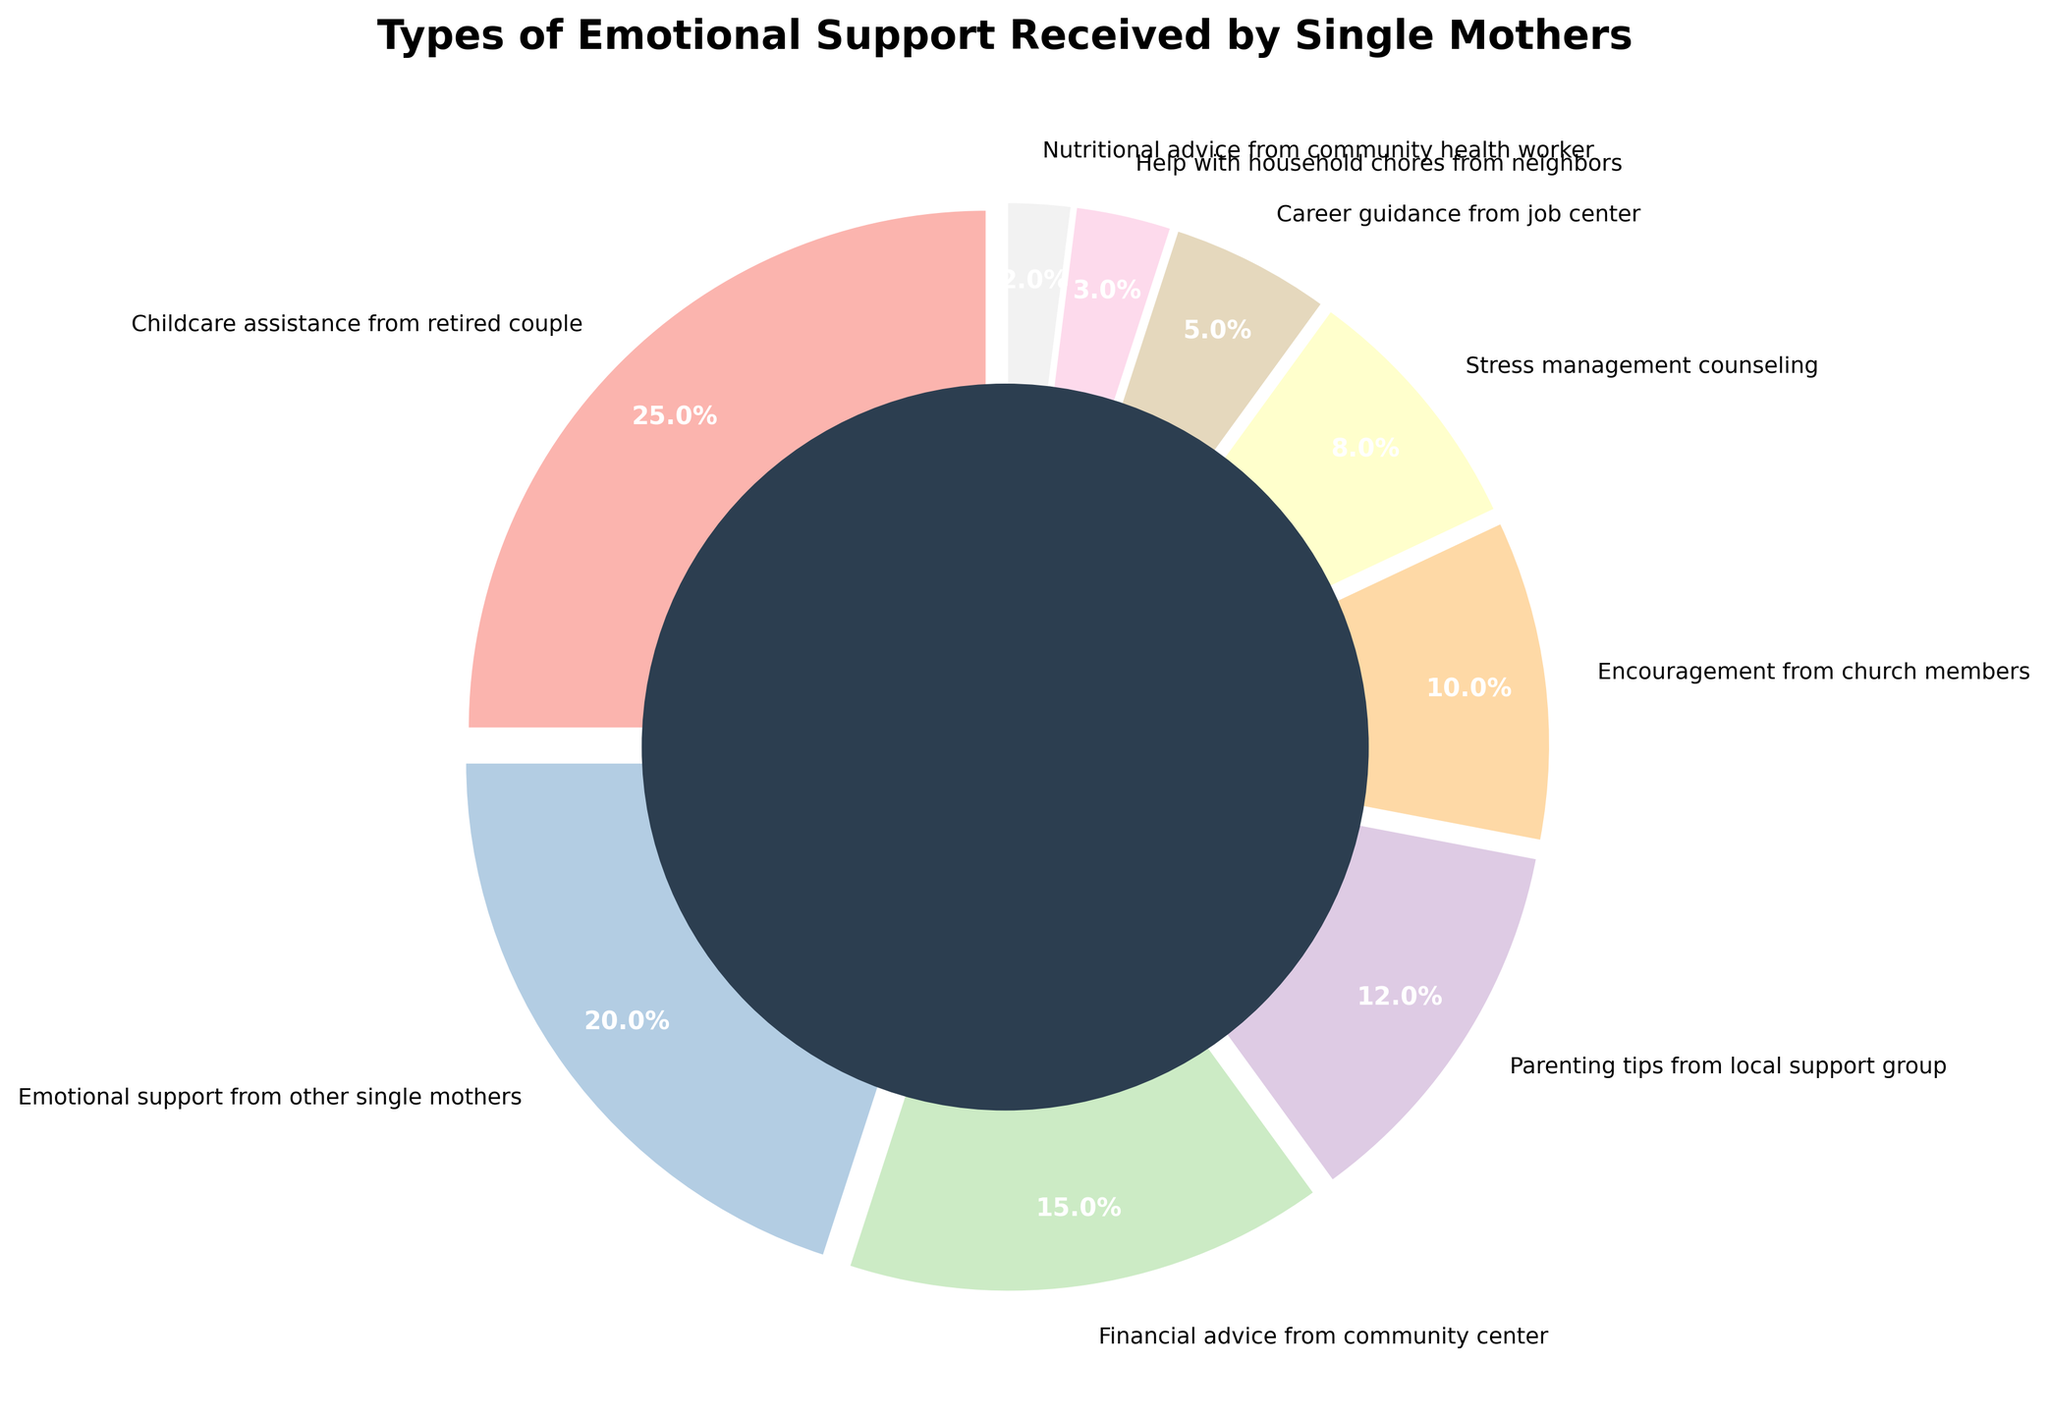what is the type of emotional support received by the most single mothers? The pie chart shows the percentages of different types of emotional support received by single mothers. The largest wedge represents "Childcare assistance from retired couple," which is 25%.
Answer: "Childcare assistance from retired couple" What is the combined percentage of single mothers receiving "Emotional support from other single mothers" and "Financial advice from community center"? Add up the percentage values for "Emotional support from other single mothers" (20%) and "Financial advice from community center" (15%). The total combined percentage is 20% + 15% = 35%.
Answer: 35% Which type of emotional support is received by fewer single mothers: "Career guidance from job center" or "Help with household chores from neighbors"? Observe the corresponding percentage values on the chart. "Career guidance from job center" is 5%, and "Help with household chores from neighbors" is 3%. Since 3% is less than 5%, fewer single mothers receive help with household chores from neighbors.
Answer: "Help with household chores from neighbors" What support type and percentage has the smallest wedge in the pie chart? The smallest wedge represents "Nutritional advice from community health worker," which has a percentage of 2%.
Answer: "Nutritional advice from community health worker", 2% Calculate the total percentage of single mothers who receive encouragement from church members, stress management counseling, and career guidance from the job center. Sum the percentage values of "Encouragement from church members" (10%), "Stress management counseling" (8%), and "Career guidance from job center" (5%). The total is 10% + 8% + 5% = 23%.
Answer: 23% Compare the percentage of single mothers receiving "Parenting tips from local support group" to those receiving "Emotional support from other single mothers." Which is higher and by how much? Look at their respective percentage values. "Parenting tips from local support group" is 12%, and "Emotional support from other single mothers" is 20%. 20% is higher, and the difference is 20% - 12% = 8%.
Answer: "Emotional support from other single mothers" by 8% What unique visual feature is used in the pie chart to create a more distinctive appearance? The pie chart employs an "explode" effect by slightly separating each wedge from the center, helping to distinguish each segment visually.
Answer: "Explode" effect 